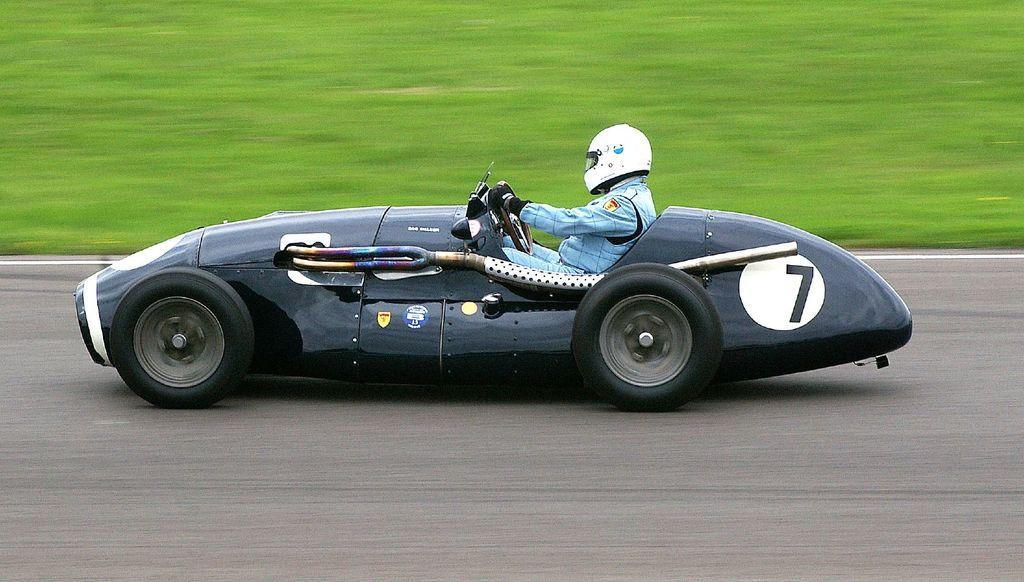What is the person in the image doing? The person is sitting and riding a vehicle. What safety gear is the person wearing? The person is wearing a helmet and gloves. What can be seen in the background of the image? There is grass in the background of the image. What is the color of the grass? The grass is green in color. What type of trucks can be seen in the image? There are no trucks present in the image. Is the person's sister riding the vehicle with them in the image? There is no mention of a sister or any other person in the image, only the person riding the vehicle. Can you see a monkey in the image? There is no monkey present in the image. 